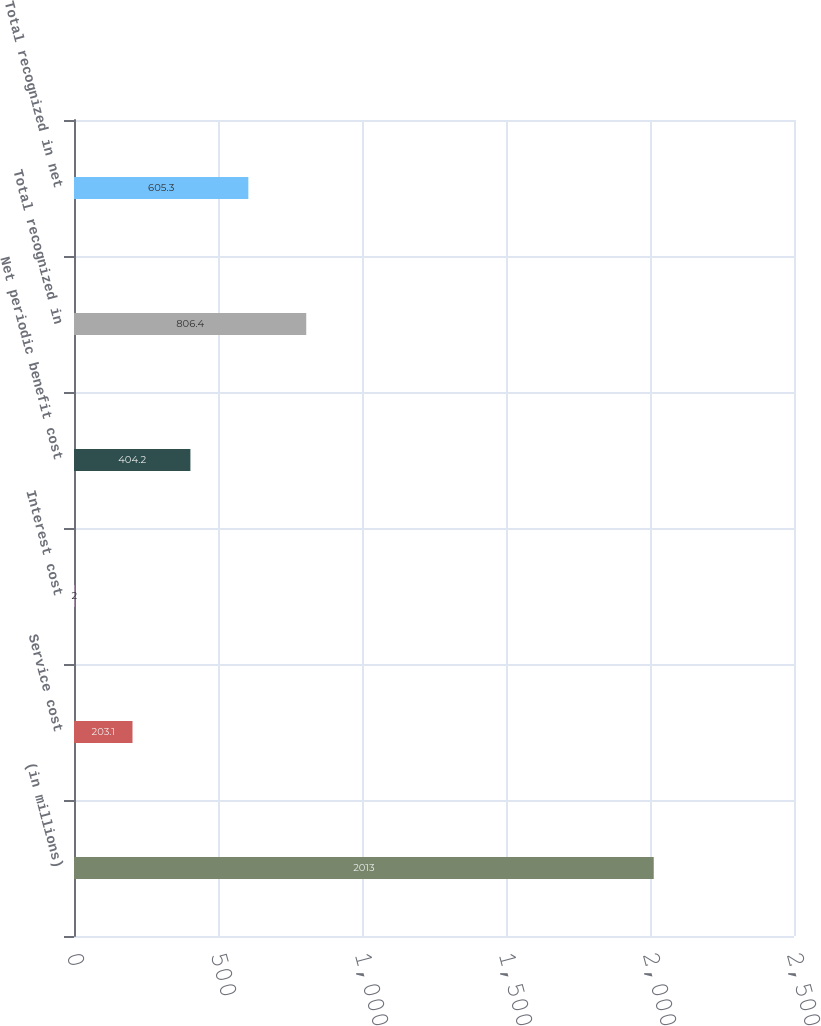Convert chart to OTSL. <chart><loc_0><loc_0><loc_500><loc_500><bar_chart><fcel>(in millions)<fcel>Service cost<fcel>Interest cost<fcel>Net periodic benefit cost<fcel>Total recognized in<fcel>Total recognized in net<nl><fcel>2013<fcel>203.1<fcel>2<fcel>404.2<fcel>806.4<fcel>605.3<nl></chart> 